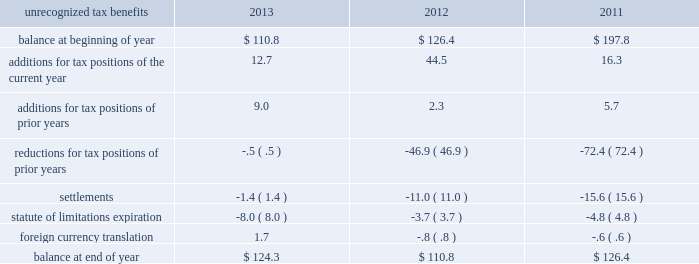Earnings were remitted as dividends after payment of all deferred taxes .
As more than 90% ( 90 % ) of the undistributed earnings are in countries with a statutory tax rate of 24% ( 24 % ) or higher , we do not generate a disproportionate amount of taxable income in countries with very low tax rates .
A reconciliation of the beginning and ending amount of the unrecognized tax benefits is as follows: .
At 30 september 2013 and 2012 , we had $ 124.3 and $ 110.8 of unrecognized tax benefits , excluding interest and penalties , of which $ 63.1 and $ 56.9 , respectively , would impact the effective tax rate if recognized .
Interest and penalties related to unrecognized tax benefits are recorded as a component of income tax expense and totaled $ 2.4 in 2013 , $ ( 26.1 ) in 2012 , and $ ( 2.4 ) in 2011 .
Our accrued balance for interest and penalties was $ 8.1 and $ 7.2 in 2013 and 2012 , respectively .
We were challenged by the spanish tax authorities over income tax deductions taken by certain of our spanish subsidiaries during fiscal years 2005 20132011 .
In november 2011 , we reached a settlement with the spanish tax authorities for 20ac41.3 million ( $ 56 ) in resolution of all tax issues under examination .
This settlement increased our income tax expense for the fiscal year ended 30 september 2012 by $ 43.8 ( $ .20 per share ) and had a 3.3% ( 3.3 % ) impact on our effective tax rate .
As a result of this settlement , we recorded a reduction in unrecognized tax benefits of $ 6.4 for tax positions taken in prior years and $ 11.0 for settlements .
On 25 january 2012 , the spanish supreme court released its decision in favor of our spanish subsidiary related to certain tax transactions for years 1991 and 1992 , a period before we controlled this subsidiary .
As a result , in the second quarter of 2012 , we recorded a reduction in income tax expense of $ 58.3 ( $ .27 per share ) , resulting in a 4.4% ( 4.4 % ) reduction in our effective tax rate for the fiscal year ended 30 september 2012 .
As a result of this ruling , we recorded a reduction in unrecognized tax benefits of $ 38.3 for tax positions taken in prior years .
During the third quarter of 2012 , our unrecognized tax benefits increased $ 33.3 as a result of certain tax positions taken in conjunction with the disposition of our homecare business .
When resolved , these benefits will be recognized in 201cincome from discontinued operations , net of tax 201d on our consolidated income statements and will not impact our effective tax rate .
For additional information , see note 3 , discontinued operations .
In the third quarter of 2011 , a u.s .
Internal revenue service audit over tax years 2007 and 2008 was completed , resulting in a decrease in unrecognized tax benefits of $ 36.0 and a favorable impact to earnings of $ 23.9 .
This included a tax benefit of $ 8.9 ( $ .04 per share ) recognized in income from discontinued operations for fiscal year 2011 , as it relates to the previously divested u.s .
Healthcare business .
We are also currently under examination in a number of tax jurisdictions , some of which may be resolved in the next twelve months .
As a result , it is reasonably possible that a change in the unrecognized tax benefits may occur during the next twelve months .
However , quantification of an estimated range cannot be made at this time. .
Considering the years 2012 and 2013 , what is the increase observed in the balance at the end of the year? 
Rationale: is the balance of 2013 divided by the 2012's then turned into a percentage .
Computations: ((124.3 / 110.8) - 1)
Answer: 0.12184. 